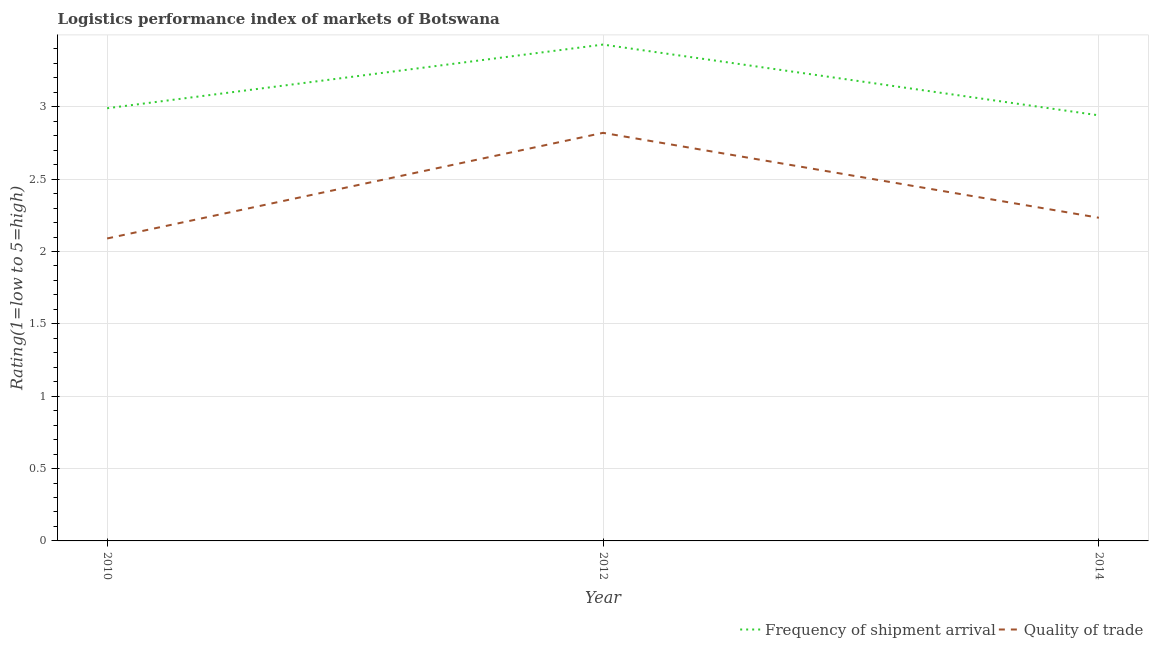How many different coloured lines are there?
Provide a succinct answer. 2. Does the line corresponding to lpi quality of trade intersect with the line corresponding to lpi of frequency of shipment arrival?
Provide a succinct answer. No. What is the lpi of frequency of shipment arrival in 2014?
Your answer should be compact. 2.94. Across all years, what is the maximum lpi quality of trade?
Your answer should be compact. 2.82. Across all years, what is the minimum lpi of frequency of shipment arrival?
Provide a short and direct response. 2.94. In which year was the lpi of frequency of shipment arrival maximum?
Make the answer very short. 2012. What is the total lpi of frequency of shipment arrival in the graph?
Your answer should be compact. 9.36. What is the difference between the lpi quality of trade in 2010 and that in 2014?
Give a very brief answer. -0.14. What is the difference between the lpi quality of trade in 2012 and the lpi of frequency of shipment arrival in 2014?
Make the answer very short. -0.12. What is the average lpi of frequency of shipment arrival per year?
Ensure brevity in your answer.  3.12. In the year 2010, what is the difference between the lpi of frequency of shipment arrival and lpi quality of trade?
Give a very brief answer. 0.9. What is the ratio of the lpi of frequency of shipment arrival in 2010 to that in 2014?
Your answer should be very brief. 1.02. Is the difference between the lpi of frequency of shipment arrival in 2012 and 2014 greater than the difference between the lpi quality of trade in 2012 and 2014?
Your response must be concise. No. What is the difference between the highest and the second highest lpi of frequency of shipment arrival?
Provide a succinct answer. 0.44. What is the difference between the highest and the lowest lpi of frequency of shipment arrival?
Offer a terse response. 0.49. Does the lpi of frequency of shipment arrival monotonically increase over the years?
Offer a terse response. No. How many years are there in the graph?
Provide a short and direct response. 3. What is the difference between two consecutive major ticks on the Y-axis?
Your answer should be compact. 0.5. Where does the legend appear in the graph?
Make the answer very short. Bottom right. How are the legend labels stacked?
Keep it short and to the point. Horizontal. What is the title of the graph?
Offer a terse response. Logistics performance index of markets of Botswana. What is the label or title of the X-axis?
Your answer should be compact. Year. What is the label or title of the Y-axis?
Ensure brevity in your answer.  Rating(1=low to 5=high). What is the Rating(1=low to 5=high) of Frequency of shipment arrival in 2010?
Provide a short and direct response. 2.99. What is the Rating(1=low to 5=high) in Quality of trade in 2010?
Your answer should be very brief. 2.09. What is the Rating(1=low to 5=high) in Frequency of shipment arrival in 2012?
Offer a terse response. 3.43. What is the Rating(1=low to 5=high) in Quality of trade in 2012?
Your response must be concise. 2.82. What is the Rating(1=low to 5=high) of Frequency of shipment arrival in 2014?
Give a very brief answer. 2.94. What is the Rating(1=low to 5=high) of Quality of trade in 2014?
Offer a terse response. 2.23. Across all years, what is the maximum Rating(1=low to 5=high) in Frequency of shipment arrival?
Ensure brevity in your answer.  3.43. Across all years, what is the maximum Rating(1=low to 5=high) in Quality of trade?
Your response must be concise. 2.82. Across all years, what is the minimum Rating(1=low to 5=high) of Frequency of shipment arrival?
Provide a short and direct response. 2.94. Across all years, what is the minimum Rating(1=low to 5=high) of Quality of trade?
Make the answer very short. 2.09. What is the total Rating(1=low to 5=high) in Frequency of shipment arrival in the graph?
Make the answer very short. 9.36. What is the total Rating(1=low to 5=high) of Quality of trade in the graph?
Provide a short and direct response. 7.14. What is the difference between the Rating(1=low to 5=high) of Frequency of shipment arrival in 2010 and that in 2012?
Make the answer very short. -0.44. What is the difference between the Rating(1=low to 5=high) in Quality of trade in 2010 and that in 2012?
Keep it short and to the point. -0.73. What is the difference between the Rating(1=low to 5=high) in Frequency of shipment arrival in 2010 and that in 2014?
Make the answer very short. 0.05. What is the difference between the Rating(1=low to 5=high) in Quality of trade in 2010 and that in 2014?
Your answer should be compact. -0.14. What is the difference between the Rating(1=low to 5=high) of Frequency of shipment arrival in 2012 and that in 2014?
Offer a very short reply. 0.49. What is the difference between the Rating(1=low to 5=high) of Quality of trade in 2012 and that in 2014?
Your answer should be very brief. 0.59. What is the difference between the Rating(1=low to 5=high) of Frequency of shipment arrival in 2010 and the Rating(1=low to 5=high) of Quality of trade in 2012?
Your answer should be compact. 0.17. What is the difference between the Rating(1=low to 5=high) in Frequency of shipment arrival in 2010 and the Rating(1=low to 5=high) in Quality of trade in 2014?
Offer a terse response. 0.76. What is the difference between the Rating(1=low to 5=high) in Frequency of shipment arrival in 2012 and the Rating(1=low to 5=high) in Quality of trade in 2014?
Your response must be concise. 1.2. What is the average Rating(1=low to 5=high) in Frequency of shipment arrival per year?
Your answer should be compact. 3.12. What is the average Rating(1=low to 5=high) of Quality of trade per year?
Your response must be concise. 2.38. In the year 2012, what is the difference between the Rating(1=low to 5=high) of Frequency of shipment arrival and Rating(1=low to 5=high) of Quality of trade?
Your response must be concise. 0.61. In the year 2014, what is the difference between the Rating(1=low to 5=high) of Frequency of shipment arrival and Rating(1=low to 5=high) of Quality of trade?
Offer a very short reply. 0.71. What is the ratio of the Rating(1=low to 5=high) of Frequency of shipment arrival in 2010 to that in 2012?
Give a very brief answer. 0.87. What is the ratio of the Rating(1=low to 5=high) in Quality of trade in 2010 to that in 2012?
Ensure brevity in your answer.  0.74. What is the ratio of the Rating(1=low to 5=high) of Frequency of shipment arrival in 2010 to that in 2014?
Keep it short and to the point. 1.02. What is the ratio of the Rating(1=low to 5=high) of Quality of trade in 2010 to that in 2014?
Provide a succinct answer. 0.94. What is the ratio of the Rating(1=low to 5=high) of Frequency of shipment arrival in 2012 to that in 2014?
Offer a very short reply. 1.17. What is the ratio of the Rating(1=low to 5=high) in Quality of trade in 2012 to that in 2014?
Make the answer very short. 1.26. What is the difference between the highest and the second highest Rating(1=low to 5=high) in Frequency of shipment arrival?
Your answer should be compact. 0.44. What is the difference between the highest and the second highest Rating(1=low to 5=high) in Quality of trade?
Provide a short and direct response. 0.59. What is the difference between the highest and the lowest Rating(1=low to 5=high) in Frequency of shipment arrival?
Offer a terse response. 0.49. What is the difference between the highest and the lowest Rating(1=low to 5=high) in Quality of trade?
Ensure brevity in your answer.  0.73. 